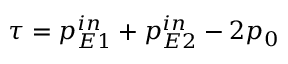Convert formula to latex. <formula><loc_0><loc_0><loc_500><loc_500>\tau = p _ { E 1 } ^ { i n } + p _ { E 2 } ^ { i n } - 2 p _ { 0 }</formula> 